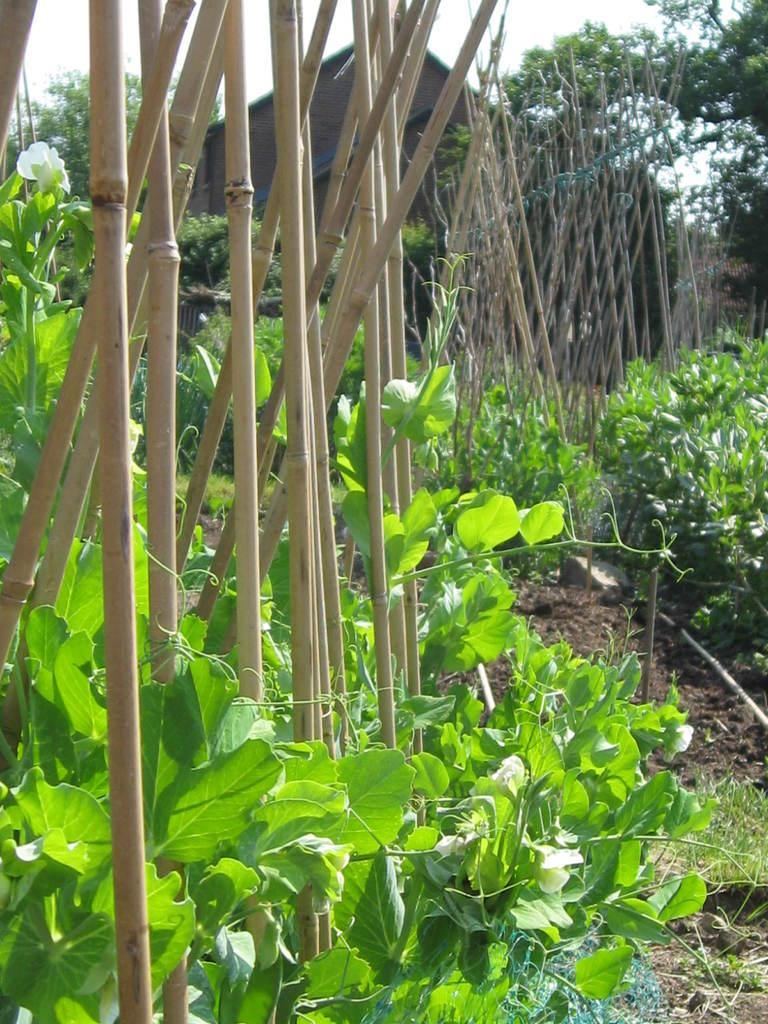How would you summarize this image in a sentence or two? In the picture I can see the plants and wooden fence. In the background, I can see a house and trees. 